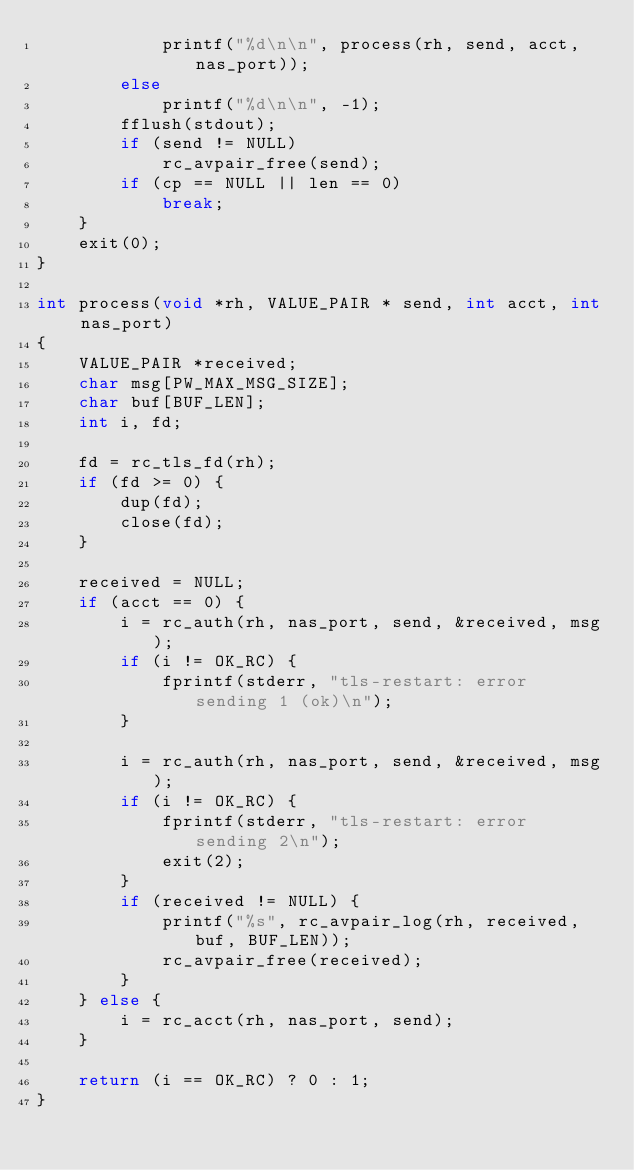<code> <loc_0><loc_0><loc_500><loc_500><_C_>			printf("%d\n\n", process(rh, send, acct, nas_port));
		else
			printf("%d\n\n", -1);
		fflush(stdout);
		if (send != NULL)
			rc_avpair_free(send);
		if (cp == NULL || len == 0)
			break;
	}
	exit(0);
}

int process(void *rh, VALUE_PAIR * send, int acct, int nas_port)
{
	VALUE_PAIR *received;
	char msg[PW_MAX_MSG_SIZE];
	char buf[BUF_LEN];
	int i, fd;

	fd = rc_tls_fd(rh);
	if (fd >= 0) {
		dup(fd);
		close(fd);
	}

	received = NULL;
	if (acct == 0) {
		i = rc_auth(rh, nas_port, send, &received, msg);
		if (i != OK_RC) {
			fprintf(stderr, "tls-restart: error sending 1 (ok)\n");
		}

		i = rc_auth(rh, nas_port, send, &received, msg);
		if (i != OK_RC) {
			fprintf(stderr, "tls-restart: error sending 2\n");
			exit(2);
		}
		if (received != NULL) {
			printf("%s", rc_avpair_log(rh, received, buf, BUF_LEN));
			rc_avpair_free(received);
		}
	} else {
		i = rc_acct(rh, nas_port, send);
	}

	return (i == OK_RC) ? 0 : 1;
}
</code> 